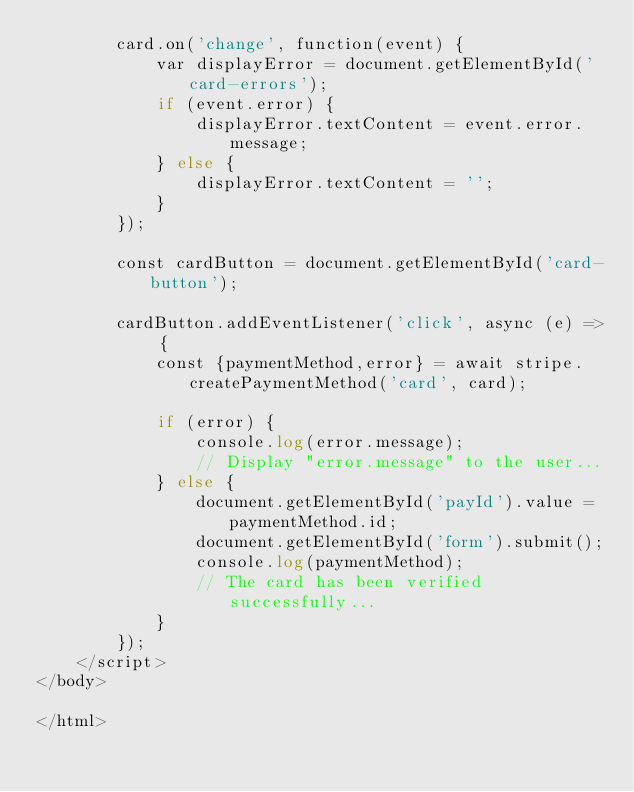Convert code to text. <code><loc_0><loc_0><loc_500><loc_500><_PHP_>        card.on('change', function(event) {
            var displayError = document.getElementById('card-errors');
            if (event.error) {
                displayError.textContent = event.error.message;
            } else {
                displayError.textContent = '';
            }
        });

        const cardButton = document.getElementById('card-button');

        cardButton.addEventListener('click', async (e) => {
            const {paymentMethod,error} = await stripe.createPaymentMethod('card', card);

            if (error) {
                console.log(error.message);
                // Display "error.message" to the user...
            } else {
                document.getElementById('payId').value = paymentMethod.id;
                document.getElementById('form').submit();
                console.log(paymentMethod);
                // The card has been verified successfully...
            }
        });
    </script>
</body>

</html>
</code> 